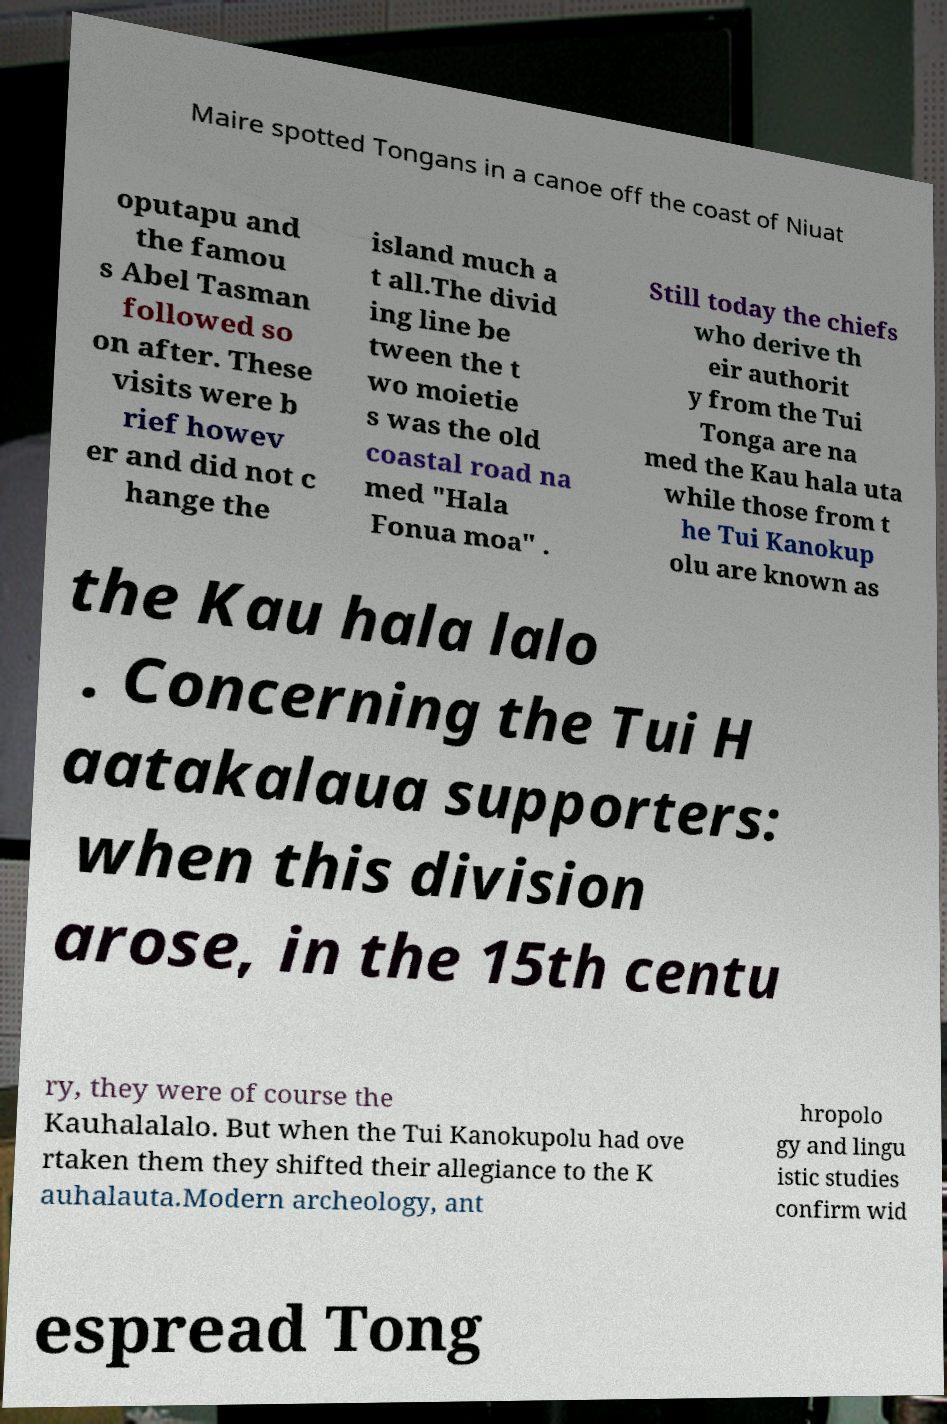Please read and relay the text visible in this image. What does it say? Maire spotted Tongans in a canoe off the coast of Niuat oputapu and the famou s Abel Tasman followed so on after. These visits were b rief howev er and did not c hange the island much a t all.The divid ing line be tween the t wo moietie s was the old coastal road na med "Hala Fonua moa" . Still today the chiefs who derive th eir authorit y from the Tui Tonga are na med the Kau hala uta while those from t he Tui Kanokup olu are known as the Kau hala lalo . Concerning the Tui H aatakalaua supporters: when this division arose, in the 15th centu ry, they were of course the Kauhalalalo. But when the Tui Kanokupolu had ove rtaken them they shifted their allegiance to the K auhalauta.Modern archeology, ant hropolo gy and lingu istic studies confirm wid espread Tong 